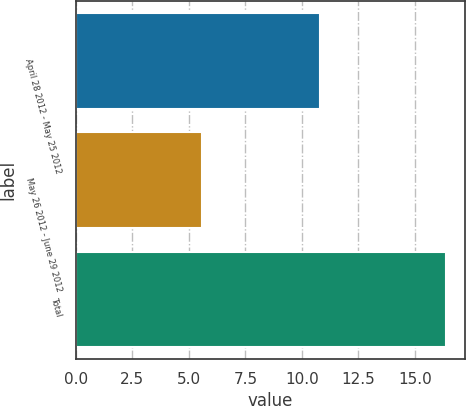<chart> <loc_0><loc_0><loc_500><loc_500><bar_chart><fcel>April 28 2012 - May 25 2012<fcel>May 26 2012 - June 29 2012<fcel>Total<nl><fcel>10.8<fcel>5.6<fcel>16.4<nl></chart> 